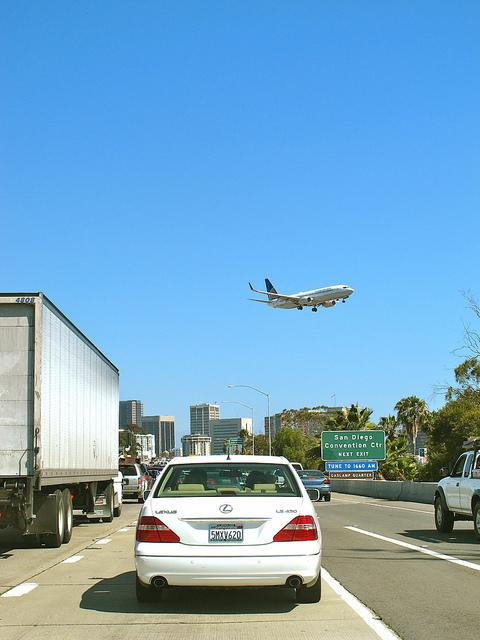This is most likely a scene from which major California city? Please explain your reasoning. san diego. The green sign on the right indicates that this city's convention center can be accessed via the next exit. the city is not san francisco, los angeles, or pasadena. 